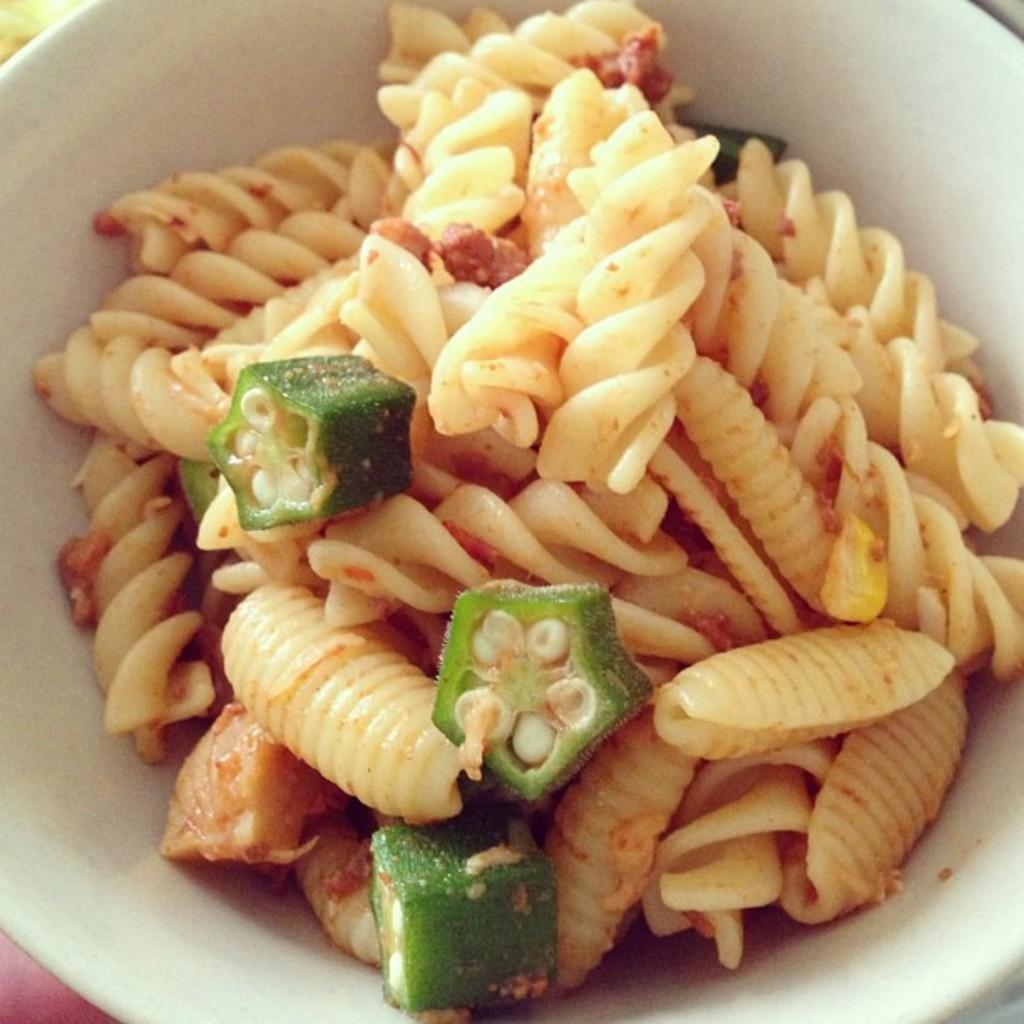What type of food is present in the image? There is macaroni and okra in the image. How are the macaroni and okra arranged in the image? The macaroni and okra are in a bowl. How many pigs are visible in the image? There are no pigs present in the image. What is the name of the place where the macaroni and okra are being served? The image does not provide information about the location or place where the macaroni and okra are being served. 